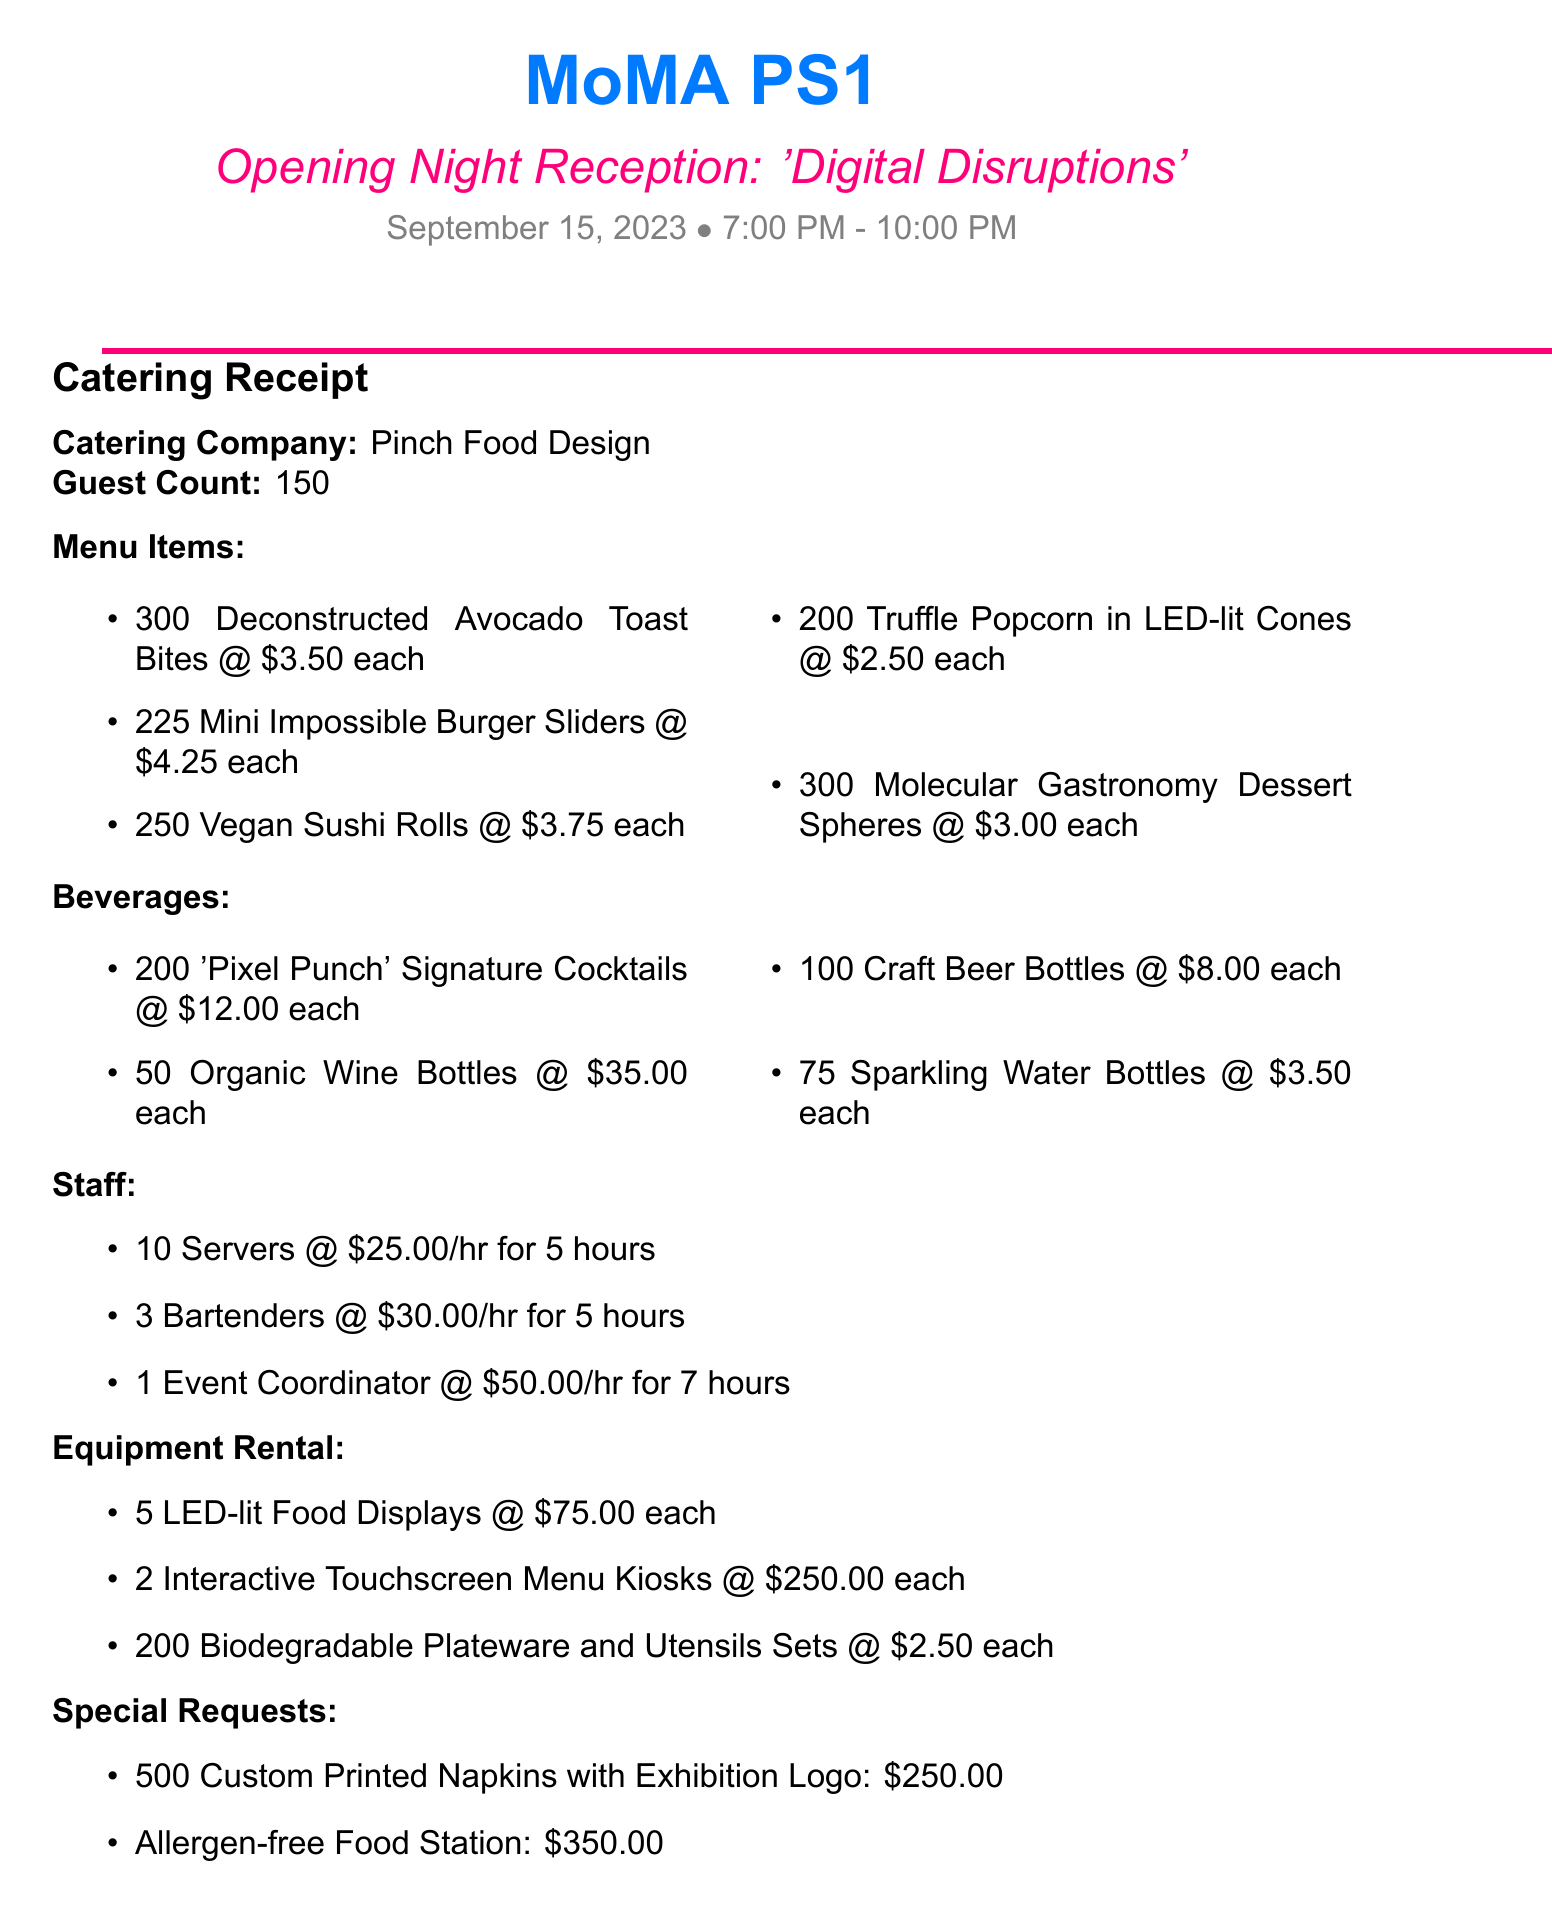what is the museum name? The museum name is prominently displayed at the top of the document.
Answer: MoMA PS1 what is the event name? The event name is listed under the museum name, specifying the occasion for the receipt.
Answer: Opening Night Reception: 'Digital Disruptions' what is the date of the event? The date of the event can be found in the header section of the document.
Answer: September 15, 2023 how many guests are expected? The guest count is stated clearly in the catering receipt section.
Answer: 150 who is the catering company? The name of the catering company is explicitly mentioned in the receipt.
Answer: Pinch Food Design what is the total cost of the event? The total cost is presented at the bottom of the receipt, summarizing all expenses.
Answer: $11,076.56 how much were the servers paid per hour? The rate for servers is specified in the staff section of the document.
Answer: $25.00 how many Mini Impossible Burger Sliders were ordered? The quantity of Mini Impossible Burger Sliders is listed under the menu items section.
Answer: 225 what is one of the special requests made for the event? One of the special requests is detailed in the special requests section.
Answer: Custom Printed Napkins with Exhibition Logo 